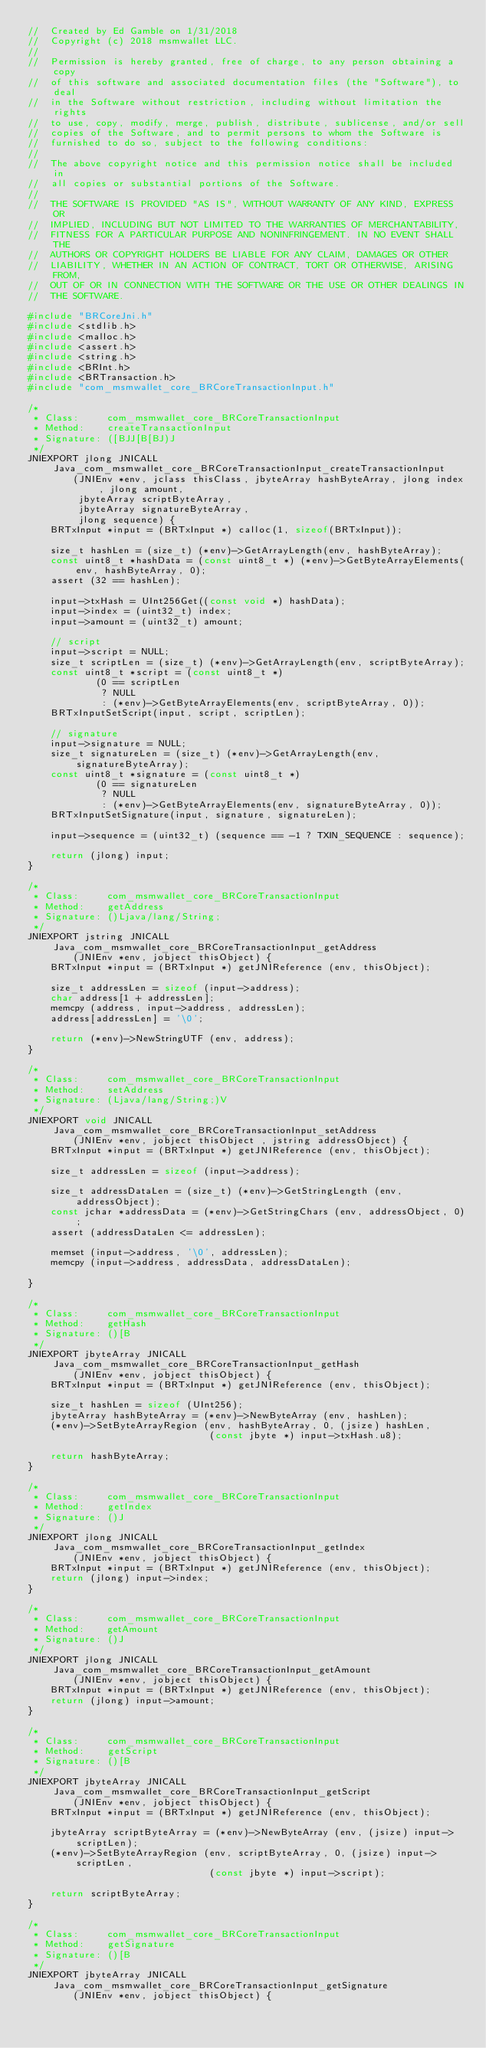Convert code to text. <code><loc_0><loc_0><loc_500><loc_500><_C_>//  Created by Ed Gamble on 1/31/2018
//  Copyright (c) 2018 msmwallet LLC.
//
//  Permission is hereby granted, free of charge, to any person obtaining a copy
//  of this software and associated documentation files (the "Software"), to deal
//  in the Software without restriction, including without limitation the rights
//  to use, copy, modify, merge, publish, distribute, sublicense, and/or sell
//  copies of the Software, and to permit persons to whom the Software is
//  furnished to do so, subject to the following conditions:
//
//  The above copyright notice and this permission notice shall be included in
//  all copies or substantial portions of the Software.
//
//  THE SOFTWARE IS PROVIDED "AS IS", WITHOUT WARRANTY OF ANY KIND, EXPRESS OR
//  IMPLIED, INCLUDING BUT NOT LIMITED TO THE WARRANTIES OF MERCHANTABILITY,
//  FITNESS FOR A PARTICULAR PURPOSE AND NONINFRINGEMENT. IN NO EVENT SHALL THE
//  AUTHORS OR COPYRIGHT HOLDERS BE LIABLE FOR ANY CLAIM, DAMAGES OR OTHER
//  LIABILITY, WHETHER IN AN ACTION OF CONTRACT, TORT OR OTHERWISE, ARISING FROM,
//  OUT OF OR IN CONNECTION WITH THE SOFTWARE OR THE USE OR OTHER DEALINGS IN
//  THE SOFTWARE.

#include "BRCoreJni.h"
#include <stdlib.h>
#include <malloc.h>
#include <assert.h>
#include <string.h>
#include <BRInt.h>
#include <BRTransaction.h>
#include "com_msmwallet_core_BRCoreTransactionInput.h"

/*
 * Class:     com_msmwallet_core_BRCoreTransactionInput
 * Method:    createTransactionInput
 * Signature: ([BJJ[B[BJ)J
 */
JNIEXPORT jlong JNICALL Java_com_msmwallet_core_BRCoreTransactionInput_createTransactionInput
        (JNIEnv *env, jclass thisClass, jbyteArray hashByteArray, jlong index, jlong amount,
         jbyteArray scriptByteArray,
         jbyteArray signatureByteArray,
         jlong sequence) {
    BRTxInput *input = (BRTxInput *) calloc(1, sizeof(BRTxInput));

    size_t hashLen = (size_t) (*env)->GetArrayLength(env, hashByteArray);
    const uint8_t *hashData = (const uint8_t *) (*env)->GetByteArrayElements(env, hashByteArray, 0);
    assert (32 == hashLen);

    input->txHash = UInt256Get((const void *) hashData);
    input->index = (uint32_t) index;
    input->amount = (uint32_t) amount;

    // script
    input->script = NULL;
    size_t scriptLen = (size_t) (*env)->GetArrayLength(env, scriptByteArray);
    const uint8_t *script = (const uint8_t *)
            (0 == scriptLen
             ? NULL
             : (*env)->GetByteArrayElements(env, scriptByteArray, 0));
    BRTxInputSetScript(input, script, scriptLen);

    // signature
    input->signature = NULL;
    size_t signatureLen = (size_t) (*env)->GetArrayLength(env, signatureByteArray);
    const uint8_t *signature = (const uint8_t *)
            (0 == signatureLen
             ? NULL
             : (*env)->GetByteArrayElements(env, signatureByteArray, 0));
    BRTxInputSetSignature(input, signature, signatureLen);

    input->sequence = (uint32_t) (sequence == -1 ? TXIN_SEQUENCE : sequence);

    return (jlong) input;
}

/*
 * Class:     com_msmwallet_core_BRCoreTransactionInput
 * Method:    getAddress
 * Signature: ()Ljava/lang/String;
 */
JNIEXPORT jstring JNICALL Java_com_msmwallet_core_BRCoreTransactionInput_getAddress
        (JNIEnv *env, jobject thisObject) {
    BRTxInput *input = (BRTxInput *) getJNIReference (env, thisObject);
    
    size_t addressLen = sizeof (input->address);
    char address[1 + addressLen];
    memcpy (address, input->address, addressLen);
    address[addressLen] = '\0';

    return (*env)->NewStringUTF (env, address);
}

/*
 * Class:     com_msmwallet_core_BRCoreTransactionInput
 * Method:    setAddress
 * Signature: (Ljava/lang/String;)V
 */
JNIEXPORT void JNICALL Java_com_msmwallet_core_BRCoreTransactionInput_setAddress
        (JNIEnv *env, jobject thisObject , jstring addressObject) {
    BRTxInput *input = (BRTxInput *) getJNIReference (env, thisObject);
    
    size_t addressLen = sizeof (input->address);

    size_t addressDataLen = (size_t) (*env)->GetStringLength (env, addressObject);
    const jchar *addressData = (*env)->GetStringChars (env, addressObject, 0);
    assert (addressDataLen <= addressLen);

    memset (input->address, '\0', addressLen);
    memcpy (input->address, addressData, addressDataLen);

}

/*
 * Class:     com_msmwallet_core_BRCoreTransactionInput
 * Method:    getHash
 * Signature: ()[B
 */
JNIEXPORT jbyteArray JNICALL Java_com_msmwallet_core_BRCoreTransactionInput_getHash
        (JNIEnv *env, jobject thisObject) {
    BRTxInput *input = (BRTxInput *) getJNIReference (env, thisObject);

    size_t hashLen = sizeof (UInt256);
    jbyteArray hashByteArray = (*env)->NewByteArray (env, hashLen);
    (*env)->SetByteArrayRegion (env, hashByteArray, 0, (jsize) hashLen, 
                                (const jbyte *) input->txHash.u8);
    
    return hashByteArray;
}

/*
 * Class:     com_msmwallet_core_BRCoreTransactionInput
 * Method:    getIndex
 * Signature: ()J
 */
JNIEXPORT jlong JNICALL Java_com_msmwallet_core_BRCoreTransactionInput_getIndex
        (JNIEnv *env, jobject thisObject) {
    BRTxInput *input = (BRTxInput *) getJNIReference (env, thisObject);
    return (jlong) input->index;
}

/*
 * Class:     com_msmwallet_core_BRCoreTransactionInput
 * Method:    getAmount
 * Signature: ()J
 */
JNIEXPORT jlong JNICALL Java_com_msmwallet_core_BRCoreTransactionInput_getAmount
        (JNIEnv *env, jobject thisObject) {
    BRTxInput *input = (BRTxInput *) getJNIReference (env, thisObject);
    return (jlong) input->amount;
}

/*
 * Class:     com_msmwallet_core_BRCoreTransactionInput
 * Method:    getScript
 * Signature: ()[B
 */
JNIEXPORT jbyteArray JNICALL Java_com_msmwallet_core_BRCoreTransactionInput_getScript
        (JNIEnv *env, jobject thisObject) {
    BRTxInput *input = (BRTxInput *) getJNIReference (env, thisObject);
    
    jbyteArray scriptByteArray = (*env)->NewByteArray (env, (jsize) input->scriptLen);
    (*env)->SetByteArrayRegion (env, scriptByteArray, 0, (jsize) input->scriptLen,
                                (const jbyte *) input->script);
    
    return scriptByteArray;
}

/*
 * Class:     com_msmwallet_core_BRCoreTransactionInput
 * Method:    getSignature
 * Signature: ()[B
 */
JNIEXPORT jbyteArray JNICALL Java_com_msmwallet_core_BRCoreTransactionInput_getSignature
        (JNIEnv *env, jobject thisObject) {</code> 